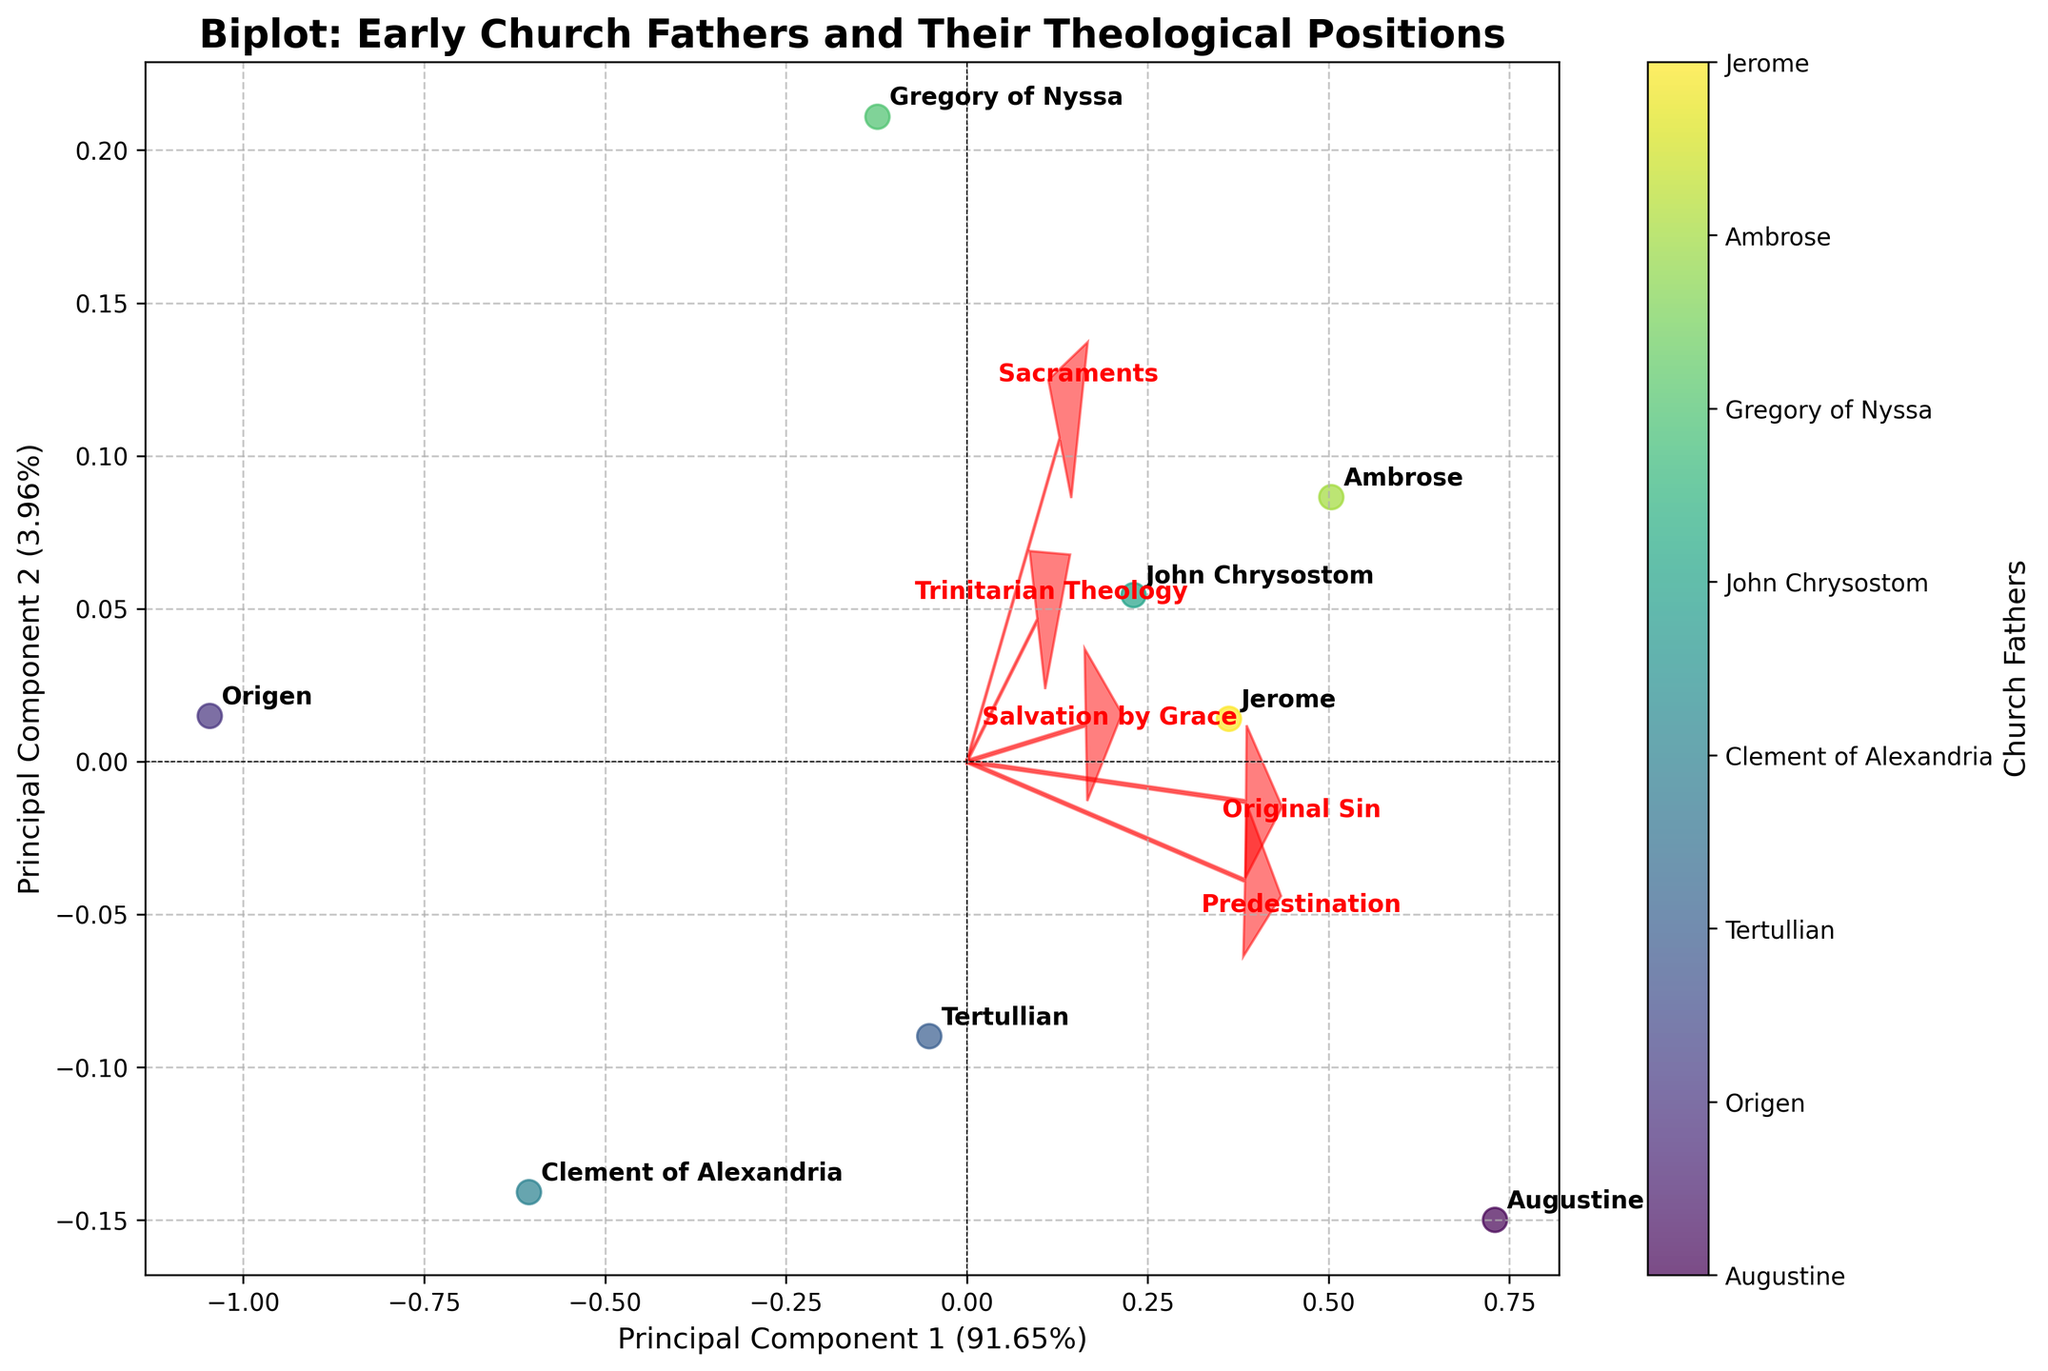What is the title of the figure? The title of the figure is prominently displayed at the top.
Answer: Biplot: Early Church Fathers and Their Theological Positions How many Church Fathers are represented in the plot? Count the different data points labeled with the names of the Church Fathers.
Answer: 8 Which theological position is represented by the arrow pointing most vertically upward? Identify the arrow that points closest to the vertical direction and read its label.
Answer: Sacraments Which Church Father is closest to the origin (0,0)? Locate the data point closest to the center of the plot.
Answer: Clement of Alexandria Which two Church Fathers have the most similar positions on the Principal Component 1 axis? Compare the data points’ positions along the horizontal axis and identify the closest pair.
Answer: Augustine and Ambrose What percentage of the total variation does the first principal component explain? Read the label of the x-axis, which should include this percentage.
Answer: 60.24% How does Origen's position on Trinitarian Theology compare to Augustine's? Compare the x-coordinates (or projection values on the Trinitarian Theology vector) of both Church Fathers.
Answer: Origen's position is lower Which theological issue contributes most strongly to the second principal component? Identify which arrow has the largest projection on the vertical axis.
Answer: Sacraments What can you infer about John Chrysostom's position on Predestination relative to Gregory of Nyssa? Compare the positions of John Chrysostom and Gregory of Nyssa in relation to the Predestination arrow.
Answer: John Chrysostom's position is higher If you consider Principal Component 1, which Church Father is the outlier concerning Original Sin? Examine the projection values on the Original Sin vector and identify the data point farthest from the pattern.
Answer: Origen 